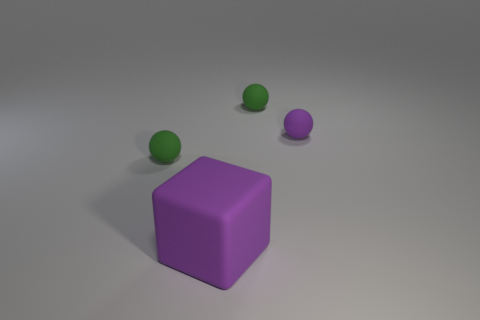Subtract all green balls. How many were subtracted if there are1green balls left? 1 Add 3 purple things. How many objects exist? 7 Subtract all balls. How many objects are left? 1 Subtract all tiny green shiny cubes. Subtract all purple objects. How many objects are left? 2 Add 4 purple matte objects. How many purple matte objects are left? 6 Add 2 tiny green things. How many tiny green things exist? 4 Subtract 0 red spheres. How many objects are left? 4 